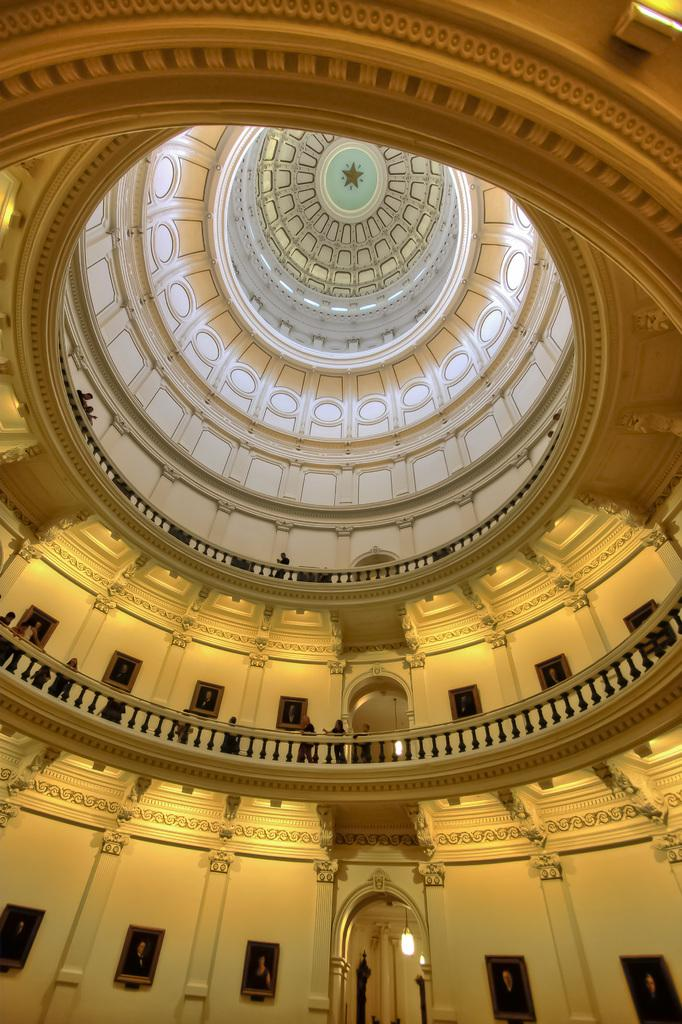What type of view is shown in the image? The image shows an inner view of a building. Can you describe the people in the image? There are people standing beside a balcony in the image. How many jellyfish can be seen swimming in the balcony area in the image? There are no jellyfish present in the image; it shows an inner view of a building with people standing beside a balcony. 